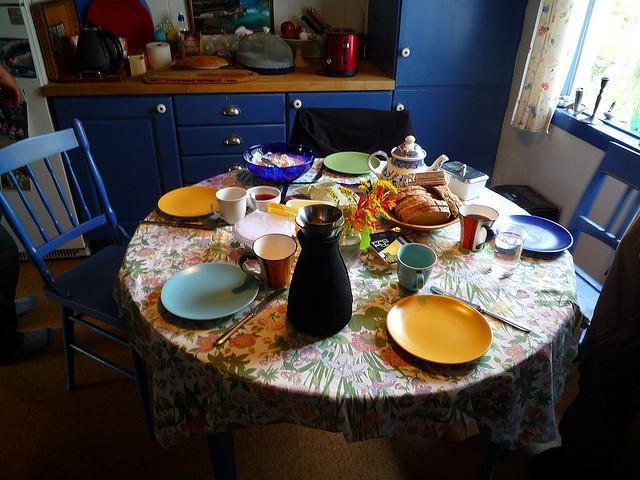How many place settings are at the table?
Give a very brief answer. 5. How many people can sit in chairs?
Give a very brief answer. 3. How many chairs are in the picture?
Give a very brief answer. 3. 